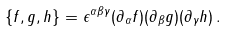Convert formula to latex. <formula><loc_0><loc_0><loc_500><loc_500>\{ f , g , h \} = \epsilon ^ { \alpha \beta \gamma } ( \partial _ { \alpha } f ) ( \partial _ { \beta } g ) ( \partial _ { \gamma } h ) \, .</formula> 